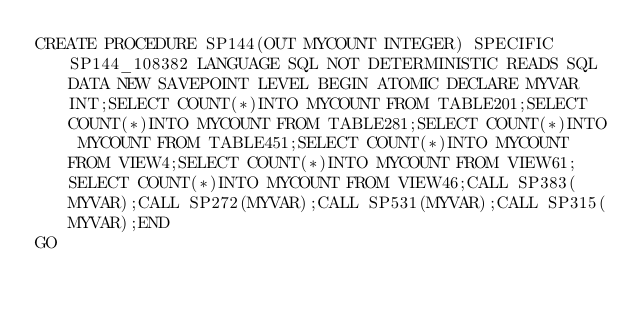Convert code to text. <code><loc_0><loc_0><loc_500><loc_500><_SQL_>CREATE PROCEDURE SP144(OUT MYCOUNT INTEGER) SPECIFIC SP144_108382 LANGUAGE SQL NOT DETERMINISTIC READS SQL DATA NEW SAVEPOINT LEVEL BEGIN ATOMIC DECLARE MYVAR INT;SELECT COUNT(*)INTO MYCOUNT FROM TABLE201;SELECT COUNT(*)INTO MYCOUNT FROM TABLE281;SELECT COUNT(*)INTO MYCOUNT FROM TABLE451;SELECT COUNT(*)INTO MYCOUNT FROM VIEW4;SELECT COUNT(*)INTO MYCOUNT FROM VIEW61;SELECT COUNT(*)INTO MYCOUNT FROM VIEW46;CALL SP383(MYVAR);CALL SP272(MYVAR);CALL SP531(MYVAR);CALL SP315(MYVAR);END
GO</code> 